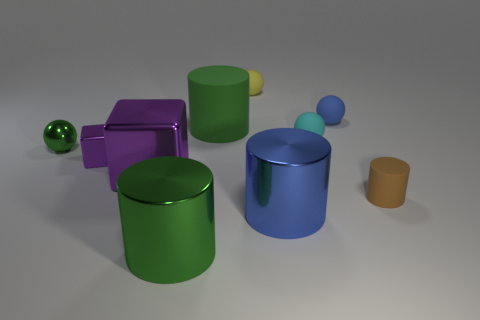Subtract all matte spheres. How many spheres are left? 1 Subtract all purple balls. Subtract all brown blocks. How many balls are left? 4 Subtract all blocks. How many objects are left? 8 Add 5 small matte balls. How many small matte balls exist? 8 Subtract 0 brown balls. How many objects are left? 10 Subtract all small purple shiny things. Subtract all green spheres. How many objects are left? 8 Add 3 large blocks. How many large blocks are left? 4 